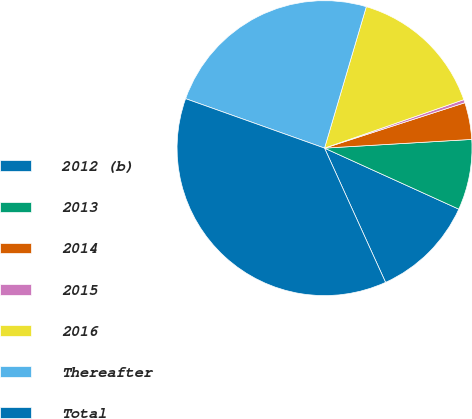Convert chart to OTSL. <chart><loc_0><loc_0><loc_500><loc_500><pie_chart><fcel>2012 (b)<fcel>2013<fcel>2014<fcel>2015<fcel>2016<fcel>Thereafter<fcel>Total<nl><fcel>11.42%<fcel>7.73%<fcel>4.04%<fcel>0.35%<fcel>15.1%<fcel>24.13%<fcel>37.24%<nl></chart> 